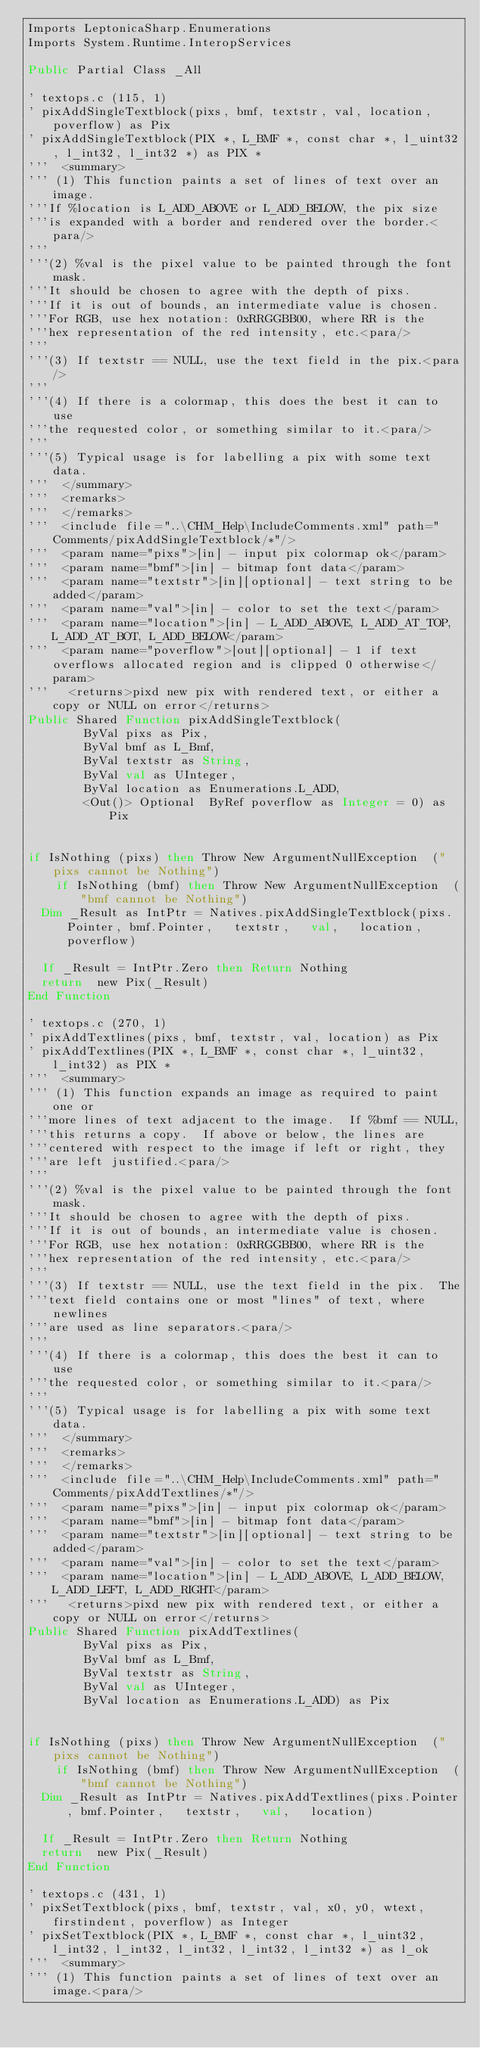<code> <loc_0><loc_0><loc_500><loc_500><_VisualBasic_>Imports LeptonicaSharp.Enumerations
Imports System.Runtime.InteropServices

Public Partial Class _All

' textops.c (115, 1)
' pixAddSingleTextblock(pixs, bmf, textstr, val, location, poverflow) as Pix
' pixAddSingleTextblock(PIX *, L_BMF *, const char *, l_uint32, l_int32, l_int32 *) as PIX *
'''  <summary>
''' (1) This function paints a set of lines of text over an image.
'''If %location is L_ADD_ABOVE or L_ADD_BELOW, the pix size
'''is expanded with a border and rendered over the border.<para/>
'''
'''(2) %val is the pixel value to be painted through the font mask.
'''It should be chosen to agree with the depth of pixs.
'''If it is out of bounds, an intermediate value is chosen.
'''For RGB, use hex notation: 0xRRGGBB00, where RR is the
'''hex representation of the red intensity, etc.<para/>
'''
'''(3) If textstr == NULL, use the text field in the pix.<para/>
'''
'''(4) If there is a colormap, this does the best it can to use
'''the requested color, or something similar to it.<para/>
'''
'''(5) Typical usage is for labelling a pix with some text data.
'''  </summary>
'''  <remarks>
'''  </remarks>
'''  <include file="..\CHM_Help\IncludeComments.xml" path="Comments/pixAddSingleTextblock/*"/>
'''  <param name="pixs">[in] - input pix colormap ok</param>
'''  <param name="bmf">[in] - bitmap font data</param>
'''  <param name="textstr">[in][optional] - text string to be added</param>
'''  <param name="val">[in] - color to set the text</param>
'''  <param name="location">[in] - L_ADD_ABOVE, L_ADD_AT_TOP, L_ADD_AT_BOT, L_ADD_BELOW</param>
'''  <param name="poverflow">[out][optional] - 1 if text overflows allocated region and is clipped 0 otherwise</param>
'''   <returns>pixd new pix with rendered text, or either a copy or NULL on error</returns>
Public Shared Function pixAddSingleTextblock(
				ByVal pixs as Pix, 
				ByVal bmf as L_Bmf, 
				ByVal textstr as String, 
				ByVal val as UInteger, 
				ByVal location as Enumerations.L_ADD, 
				<Out()> Optional  ByRef poverflow as Integer = 0) as Pix


if IsNothing (pixs) then Throw New ArgumentNullException  ("pixs cannot be Nothing")
		if IsNothing (bmf) then Throw New ArgumentNullException  ("bmf cannot be Nothing")
	Dim _Result as IntPtr = Natives.pixAddSingleTextblock(pixs.Pointer, bmf.Pointer,   textstr,   val,   location,   poverflow)
	
	If _Result = IntPtr.Zero then Return Nothing
	return  new Pix(_Result)
End Function

' textops.c (270, 1)
' pixAddTextlines(pixs, bmf, textstr, val, location) as Pix
' pixAddTextlines(PIX *, L_BMF *, const char *, l_uint32, l_int32) as PIX *
'''  <summary>
''' (1) This function expands an image as required to paint one or
'''more lines of text adjacent to the image.  If %bmf == NULL,
'''this returns a copy.  If above or below, the lines are
'''centered with respect to the image if left or right, they
'''are left justified.<para/>
'''
'''(2) %val is the pixel value to be painted through the font mask.
'''It should be chosen to agree with the depth of pixs.
'''If it is out of bounds, an intermediate value is chosen.
'''For RGB, use hex notation: 0xRRGGBB00, where RR is the
'''hex representation of the red intensity, etc.<para/>
'''
'''(3) If textstr == NULL, use the text field in the pix.  The
'''text field contains one or most "lines" of text, where newlines
'''are used as line separators.<para/>
'''
'''(4) If there is a colormap, this does the best it can to use
'''the requested color, or something similar to it.<para/>
'''
'''(5) Typical usage is for labelling a pix with some text data.
'''  </summary>
'''  <remarks>
'''  </remarks>
'''  <include file="..\CHM_Help\IncludeComments.xml" path="Comments/pixAddTextlines/*"/>
'''  <param name="pixs">[in] - input pix colormap ok</param>
'''  <param name="bmf">[in] - bitmap font data</param>
'''  <param name="textstr">[in][optional] - text string to be added</param>
'''  <param name="val">[in] - color to set the text</param>
'''  <param name="location">[in] - L_ADD_ABOVE, L_ADD_BELOW, L_ADD_LEFT, L_ADD_RIGHT</param>
'''   <returns>pixd new pix with rendered text, or either a copy or NULL on error</returns>
Public Shared Function pixAddTextlines(
				ByVal pixs as Pix, 
				ByVal bmf as L_Bmf, 
				ByVal textstr as String, 
				ByVal val as UInteger, 
				ByVal location as Enumerations.L_ADD) as Pix


if IsNothing (pixs) then Throw New ArgumentNullException  ("pixs cannot be Nothing")
		if IsNothing (bmf) then Throw New ArgumentNullException  ("bmf cannot be Nothing")
	Dim _Result as IntPtr = Natives.pixAddTextlines(pixs.Pointer, bmf.Pointer,   textstr,   val,   location)
	
	If _Result = IntPtr.Zero then Return Nothing
	return  new Pix(_Result)
End Function

' textops.c (431, 1)
' pixSetTextblock(pixs, bmf, textstr, val, x0, y0, wtext, firstindent, poverflow) as Integer
' pixSetTextblock(PIX *, L_BMF *, const char *, l_uint32, l_int32, l_int32, l_int32, l_int32, l_int32 *) as l_ok
'''  <summary>
''' (1) This function paints a set of lines of text over an image.<para/></code> 